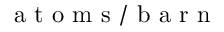Convert formula to latex. <formula><loc_0><loc_0><loc_500><loc_500>a t o m s / b a r n</formula> 